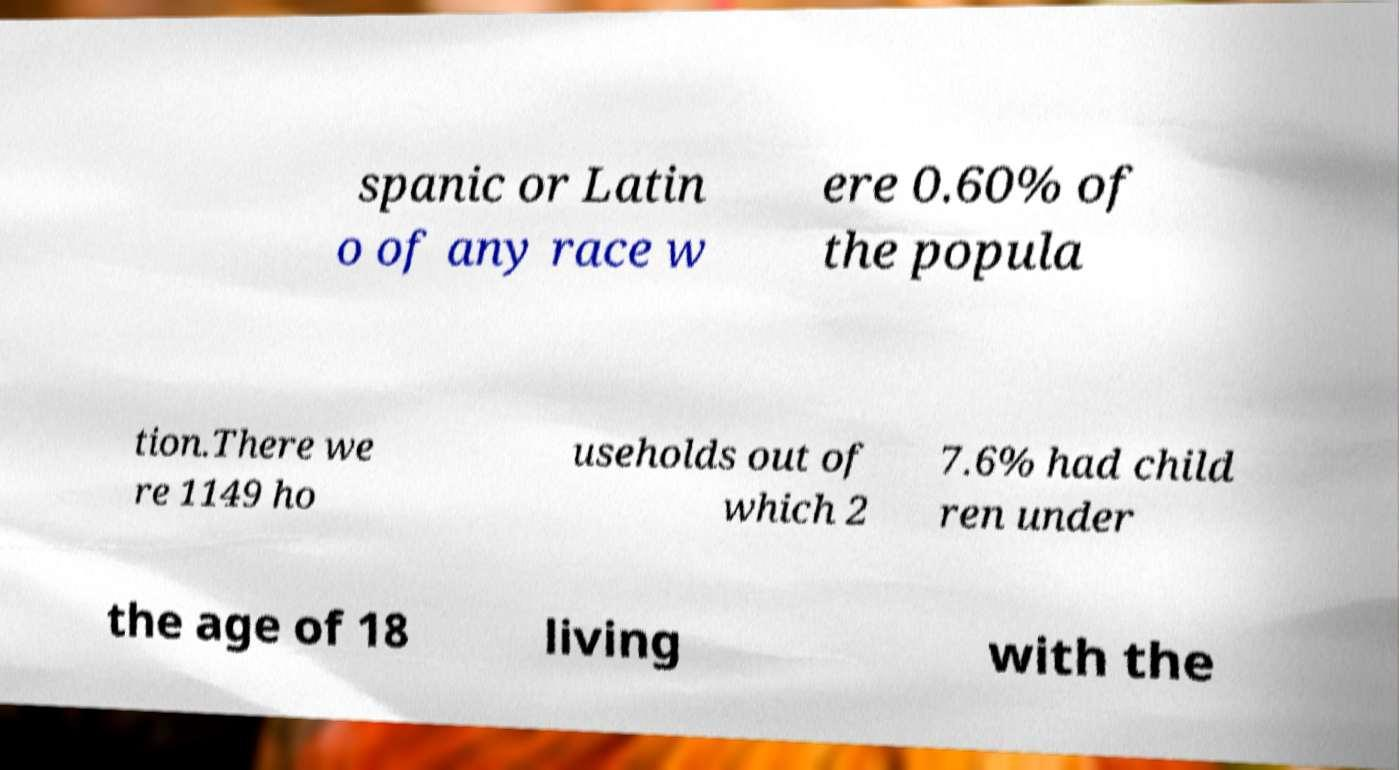For documentation purposes, I need the text within this image transcribed. Could you provide that? spanic or Latin o of any race w ere 0.60% of the popula tion.There we re 1149 ho useholds out of which 2 7.6% had child ren under the age of 18 living with the 